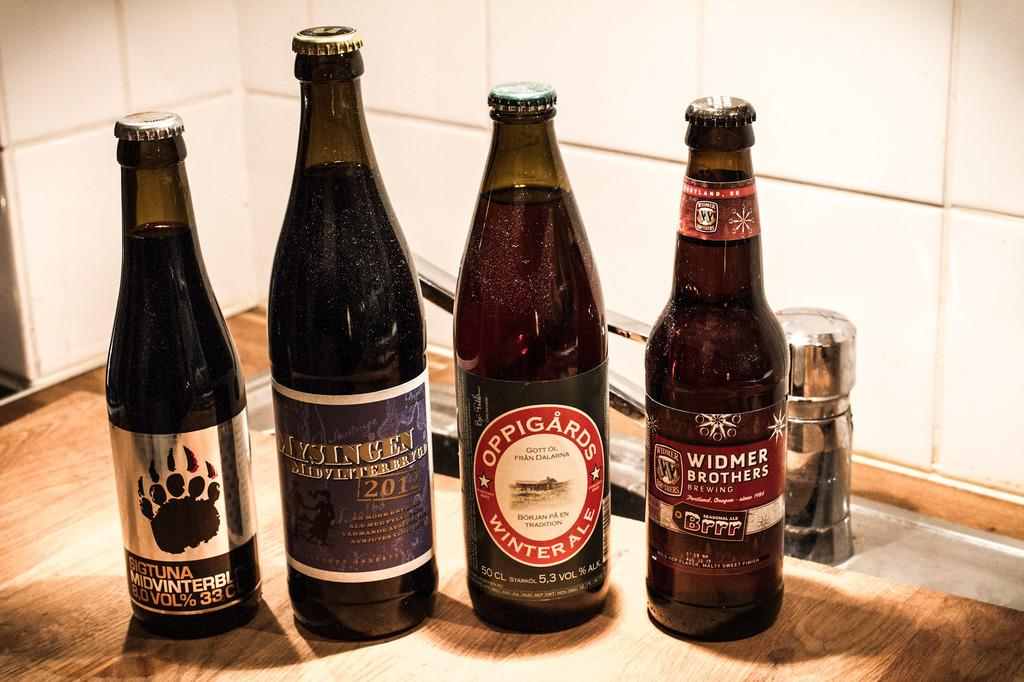What is the main object in the image? There is a wine bottle in the image. Where is the wine bottle located? The wine bottle is on a table. What type of secretary is working at the table in the image? There is no secretary present in the image; it only features a wine bottle on a table. 